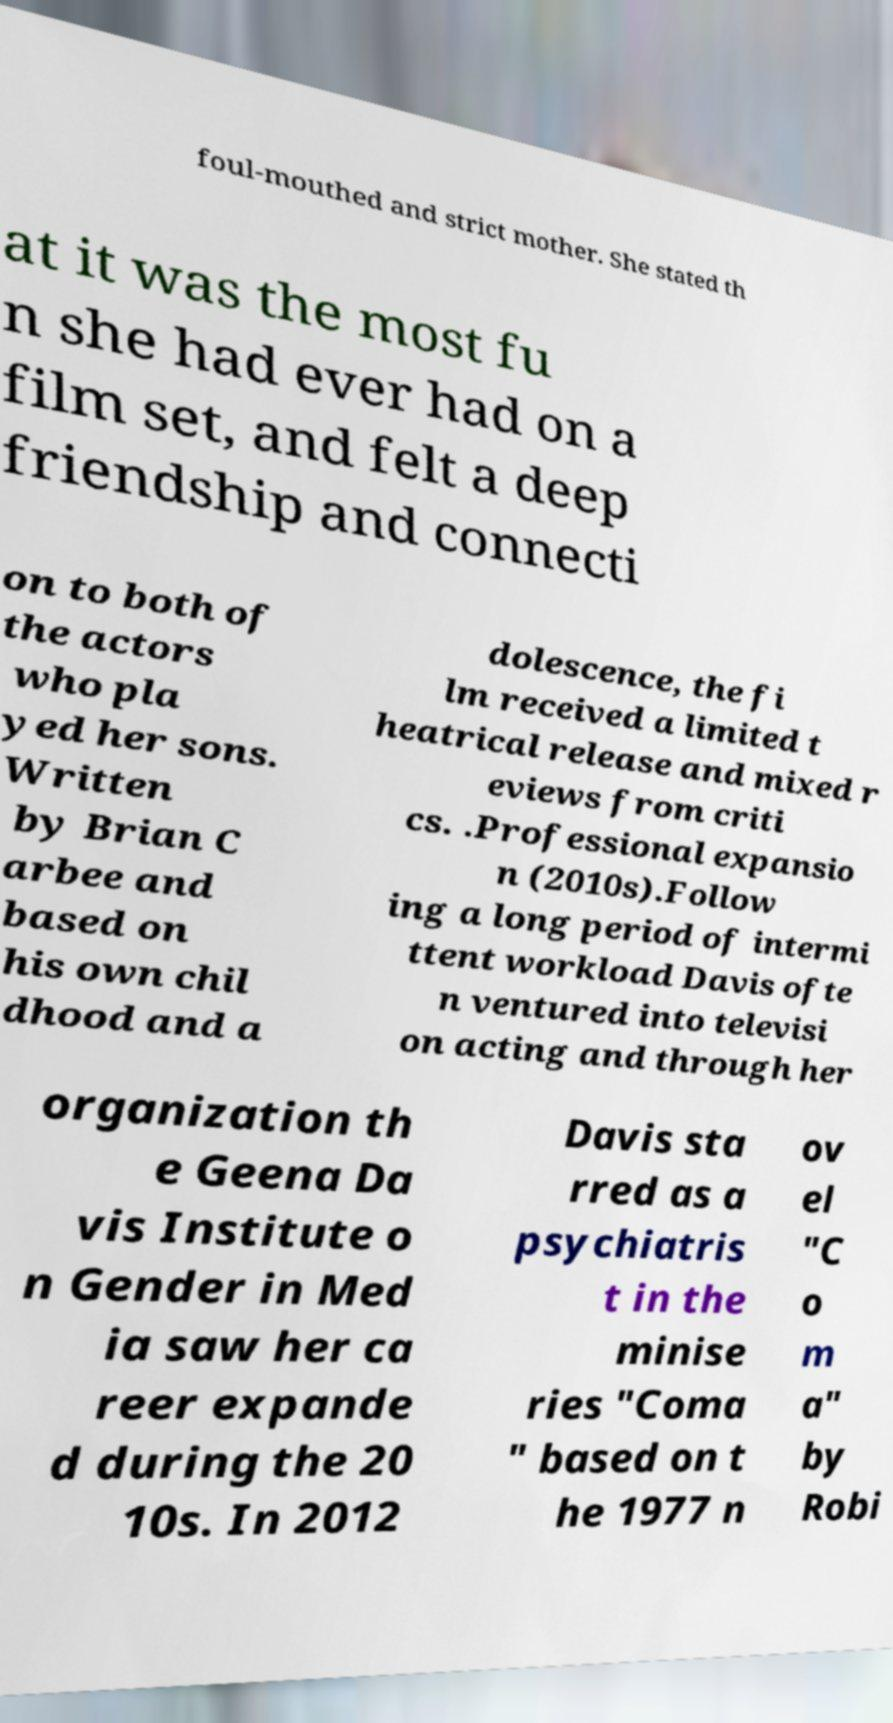Can you accurately transcribe the text from the provided image for me? foul-mouthed and strict mother. She stated th at it was the most fu n she had ever had on a film set, and felt a deep friendship and connecti on to both of the actors who pla yed her sons. Written by Brian C arbee and based on his own chil dhood and a dolescence, the fi lm received a limited t heatrical release and mixed r eviews from criti cs. .Professional expansio n (2010s).Follow ing a long period of intermi ttent workload Davis ofte n ventured into televisi on acting and through her organization th e Geena Da vis Institute o n Gender in Med ia saw her ca reer expande d during the 20 10s. In 2012 Davis sta rred as a psychiatris t in the minise ries "Coma " based on t he 1977 n ov el "C o m a" by Robi 